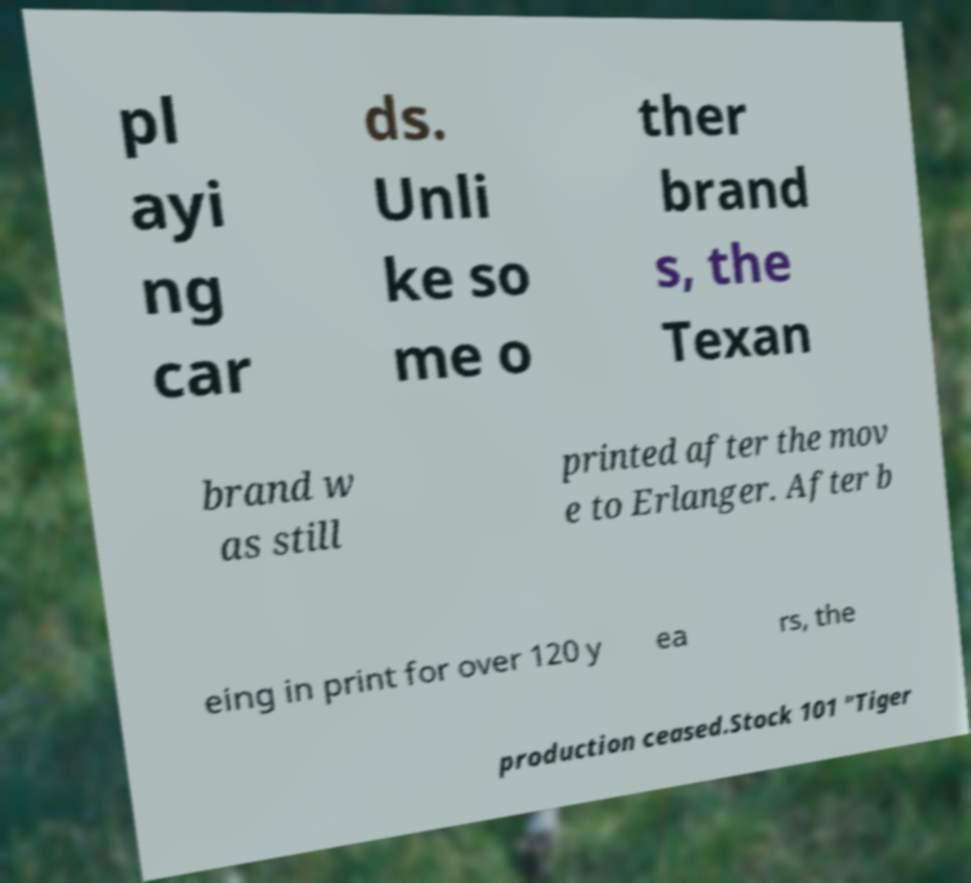Could you extract and type out the text from this image? pl ayi ng car ds. Unli ke so me o ther brand s, the Texan brand w as still printed after the mov e to Erlanger. After b eing in print for over 120 y ea rs, the production ceased.Stock 101 "Tiger 